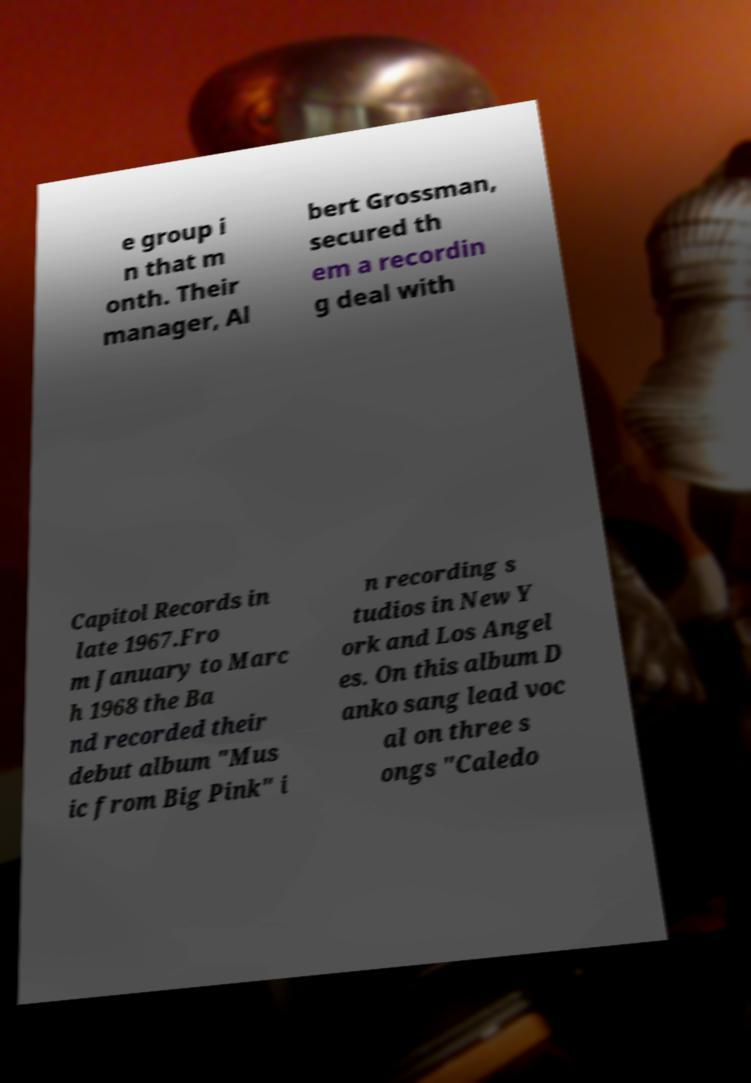I need the written content from this picture converted into text. Can you do that? e group i n that m onth. Their manager, Al bert Grossman, secured th em a recordin g deal with Capitol Records in late 1967.Fro m January to Marc h 1968 the Ba nd recorded their debut album "Mus ic from Big Pink" i n recording s tudios in New Y ork and Los Angel es. On this album D anko sang lead voc al on three s ongs "Caledo 